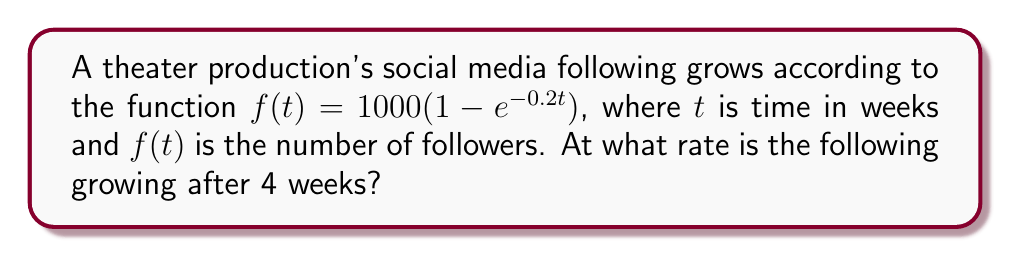Could you help me with this problem? To find the rate of growth after 4 weeks, we need to calculate the derivative of the function $f(t)$ and evaluate it at $t=4$.

Step 1: Calculate the derivative of $f(t)$.
$$\frac{d}{dt}f(t) = 1000 \cdot \frac{d}{dt}(1 - e^{-0.2t})$$
$$f'(t) = 1000 \cdot (0.2e^{-0.2t})$$
$$f'(t) = 200e^{-0.2t}$$

Step 2: Evaluate $f'(t)$ at $t=4$.
$$f'(4) = 200e^{-0.2(4)}$$
$$f'(4) = 200e^{-0.8}$$
$$f'(4) \approx 89.84$$

The rate of growth after 4 weeks is approximately 89.84 followers per week.
Answer: 89.84 followers/week 